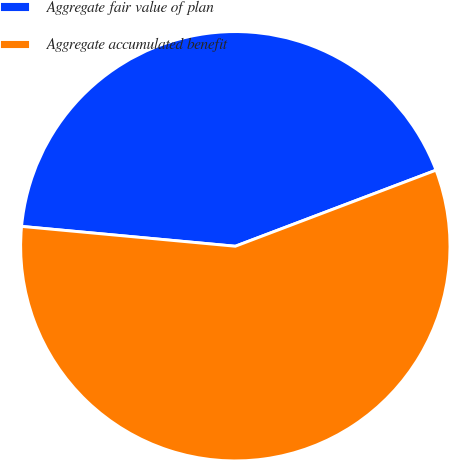Convert chart. <chart><loc_0><loc_0><loc_500><loc_500><pie_chart><fcel>Aggregate fair value of plan<fcel>Aggregate accumulated benefit<nl><fcel>42.76%<fcel>57.24%<nl></chart> 